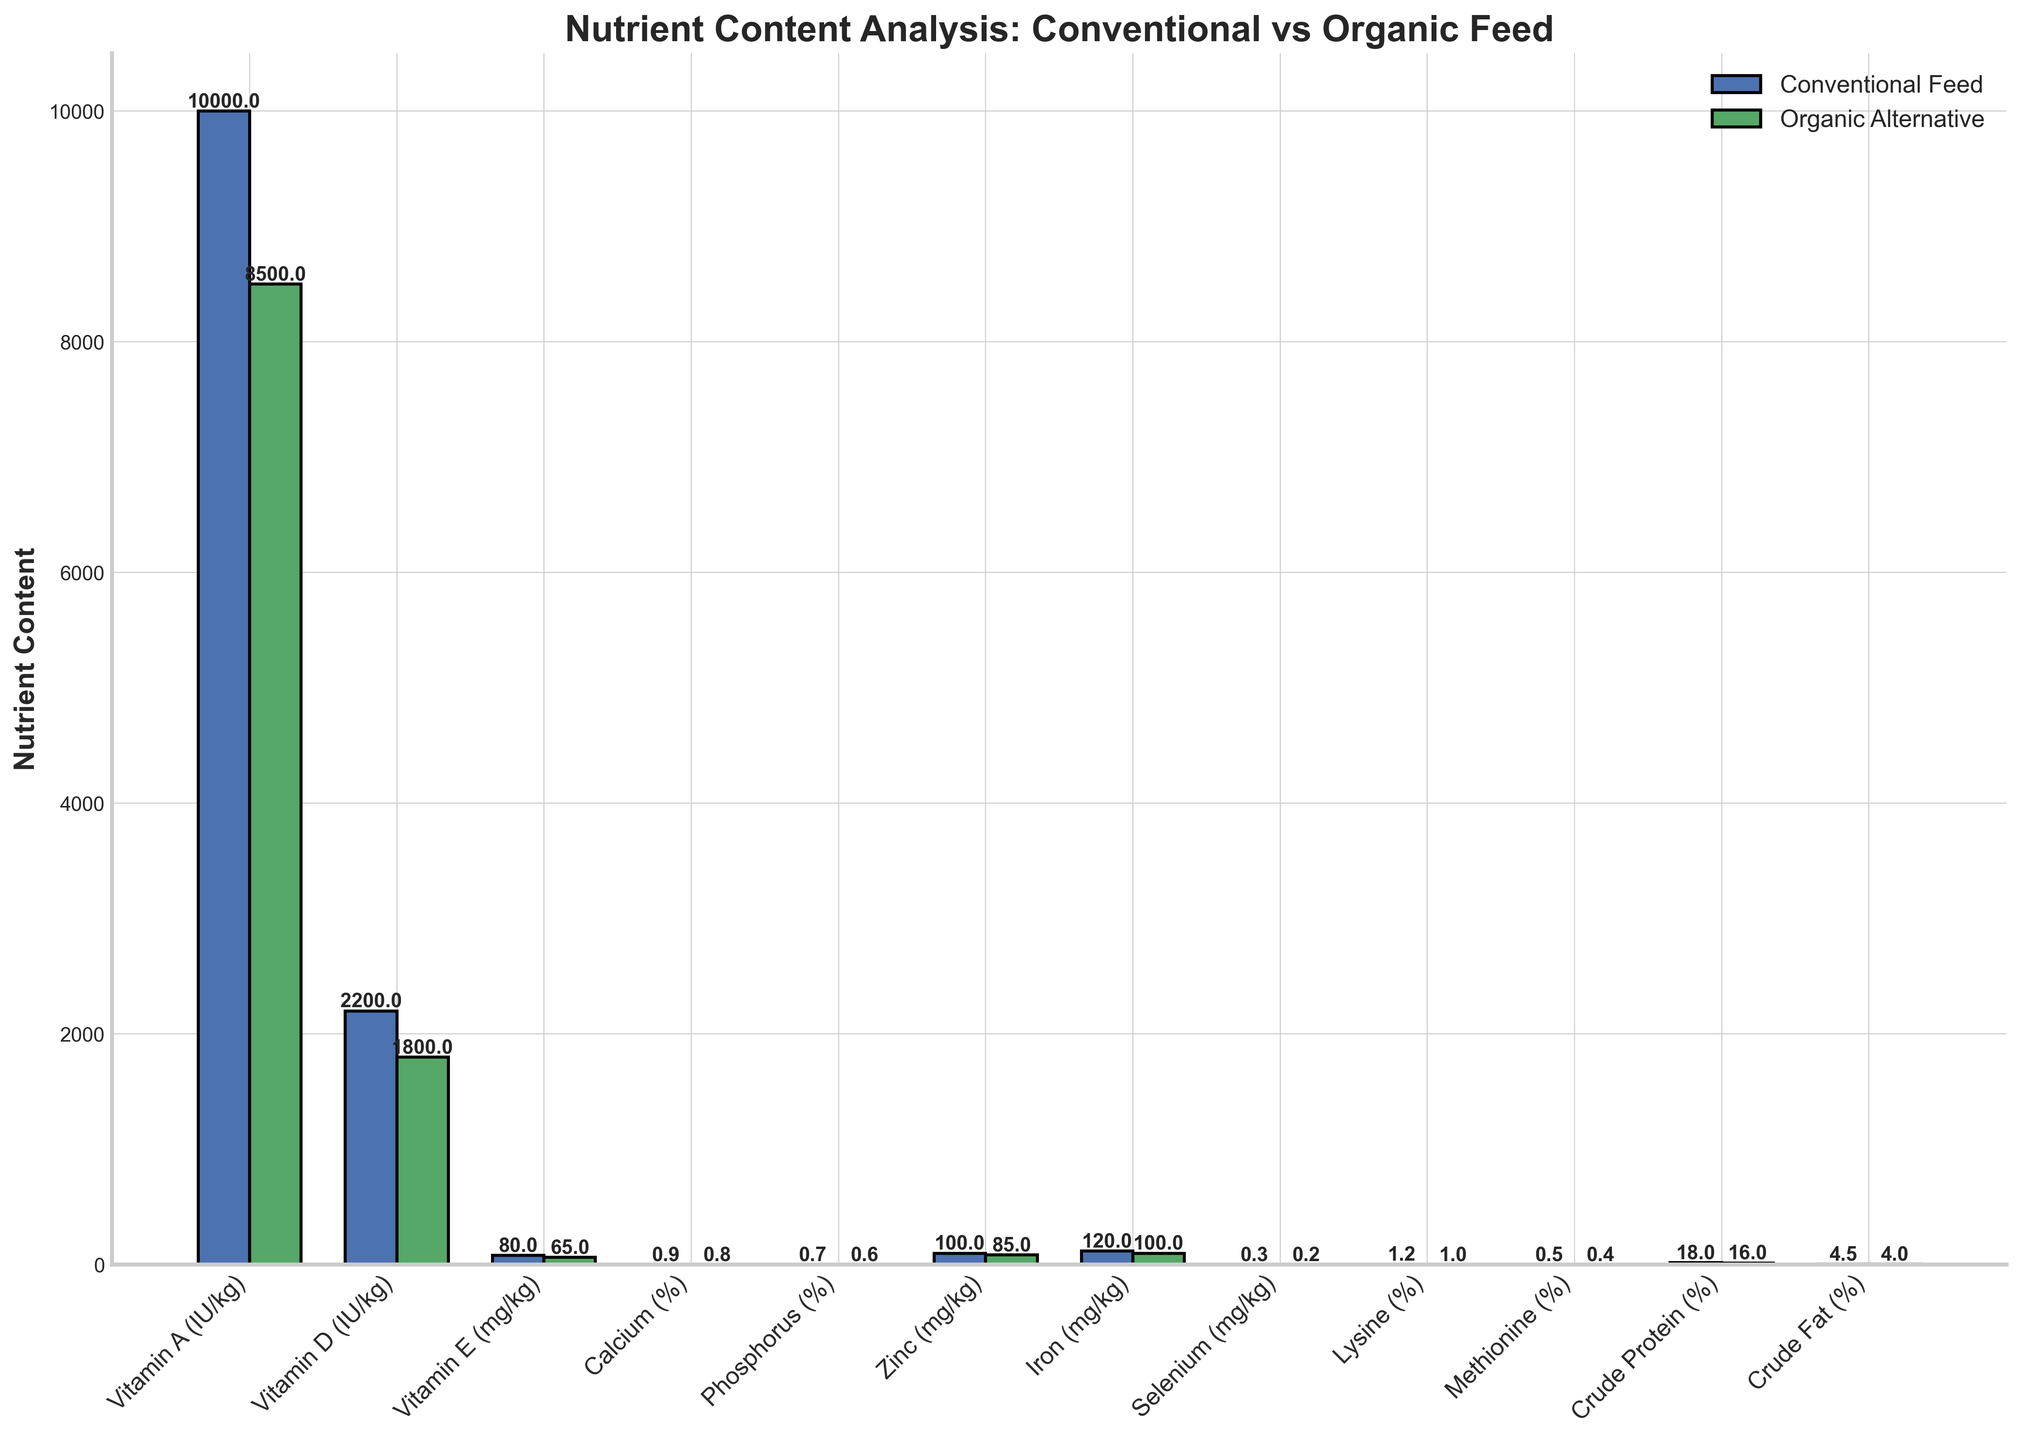Which feed has a higher content of Vitamin A? The bar representing Vitamin A shows that Conventional Feed has a higher content (10,000 IU/kg) compared to Organic Alternative (8,500 IU/kg).
Answer: Conventional Feed How much greater is the Selenium content in Conventional Feed compared to Organic Alternative? The Selenium content is 0.3 mg/kg in Conventional Feed and 0.2 mg/kg in Organic Alternative. The difference is 0.3 - 0.2 = 0.1 mg/kg.
Answer: 0.1 mg/kg What is the average crude protein content for the two types of feeds? The Crude Protein content is 18% for Conventional Feed and 16% for Organic Alternative. Their average is (18 + 16) / 2 = 17%.
Answer: 17% Which nutrient shows the largest difference in content between Conventional Feed and Organic Alternative? By comparing the bars, Vitamin A shows the largest absolute difference of 10,000 - 8,500 = 1,500 IU/kg.
Answer: Vitamin A What is the total content of Calcium and Phosphorus in Conventional Feed? The Calcium content is 0.9% and the Phosphorus content is 0.7% in Conventional Feed. Their total content is 0.9 + 0.7 = 1.6%.
Answer: 1.6% Which nutrient content is the same in both types of feeds? None of the bars align perfectly in height, indicating all the nutrient contents differ between Conventional Feed and Organic Alternative.
Answer: None If you combine the contents of Vitamin D, Zinc, and Iron in Organic Alternatives, what would be their total content? The contents are Vitamin D (1800 IU/kg), Zinc (85 mg/kg), and Iron (100 mg/kg). Total content is 1800 + 85 + 100 = 1985 (adjust for consistent units if necessary).
Answer: 1985 IU/kg and mg/kg What’s the percentage difference in Methionine content between the two feeds? Methionine content is 0.5% for Conventional Feed and 0.4% for Organic Alternative. Percentage difference is [(0.5 - 0.4) / 0.5] * 100 = 20%.
Answer: 20% Which feed has a lower content of Vitamin E? The bar representing Vitamin E shows that Organic Alternative has a lower content (65 mg/kg) compared to Conventional Feed (80 mg/kg).
Answer: Organic Alternative 